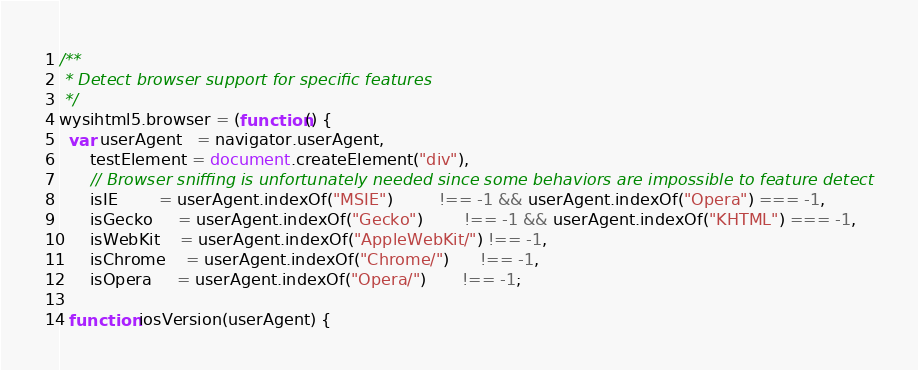<code> <loc_0><loc_0><loc_500><loc_500><_JavaScript_>/**
 * Detect browser support for specific features
 */
wysihtml5.browser = (function() {
  var userAgent   = navigator.userAgent,
      testElement = document.createElement("div"),
      // Browser sniffing is unfortunately needed since some behaviors are impossible to feature detect
      isIE        = userAgent.indexOf("MSIE")         !== -1 && userAgent.indexOf("Opera") === -1,
      isGecko     = userAgent.indexOf("Gecko")        !== -1 && userAgent.indexOf("KHTML") === -1,
      isWebKit    = userAgent.indexOf("AppleWebKit/") !== -1,
      isChrome    = userAgent.indexOf("Chrome/")      !== -1,
      isOpera     = userAgent.indexOf("Opera/")       !== -1;
  
  function iosVersion(userAgent) {</code> 